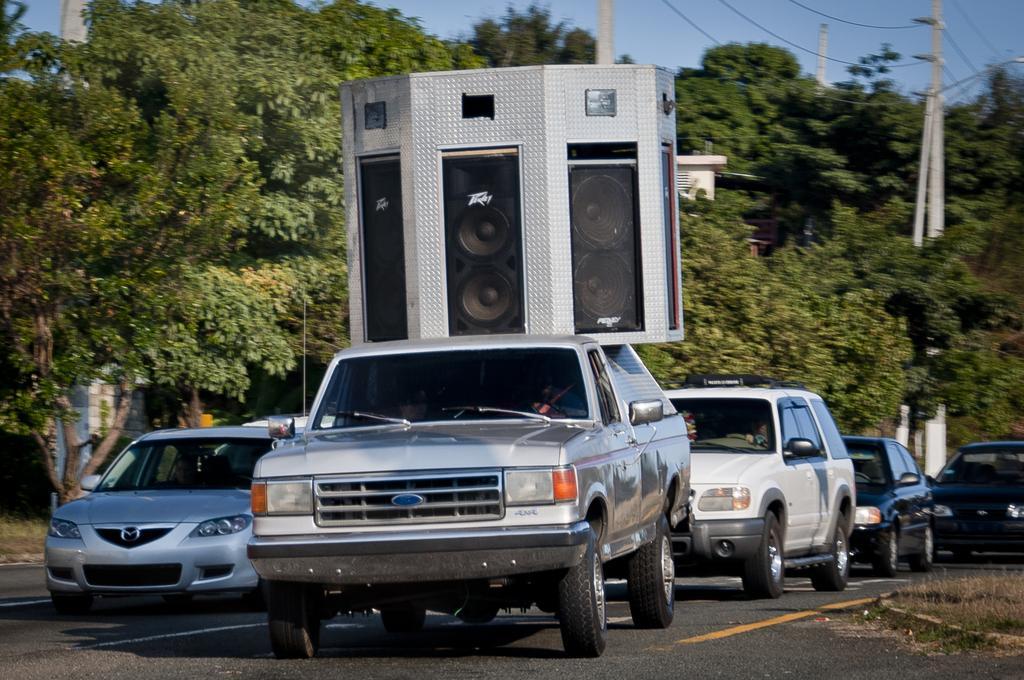Can you describe this image briefly? In this image I can see many cars on the road. In the middle of the image there are few speakers at the top of a vehicle. In the background there are many trees and poles. At the top of the image I can see the sky and also there are cables. 